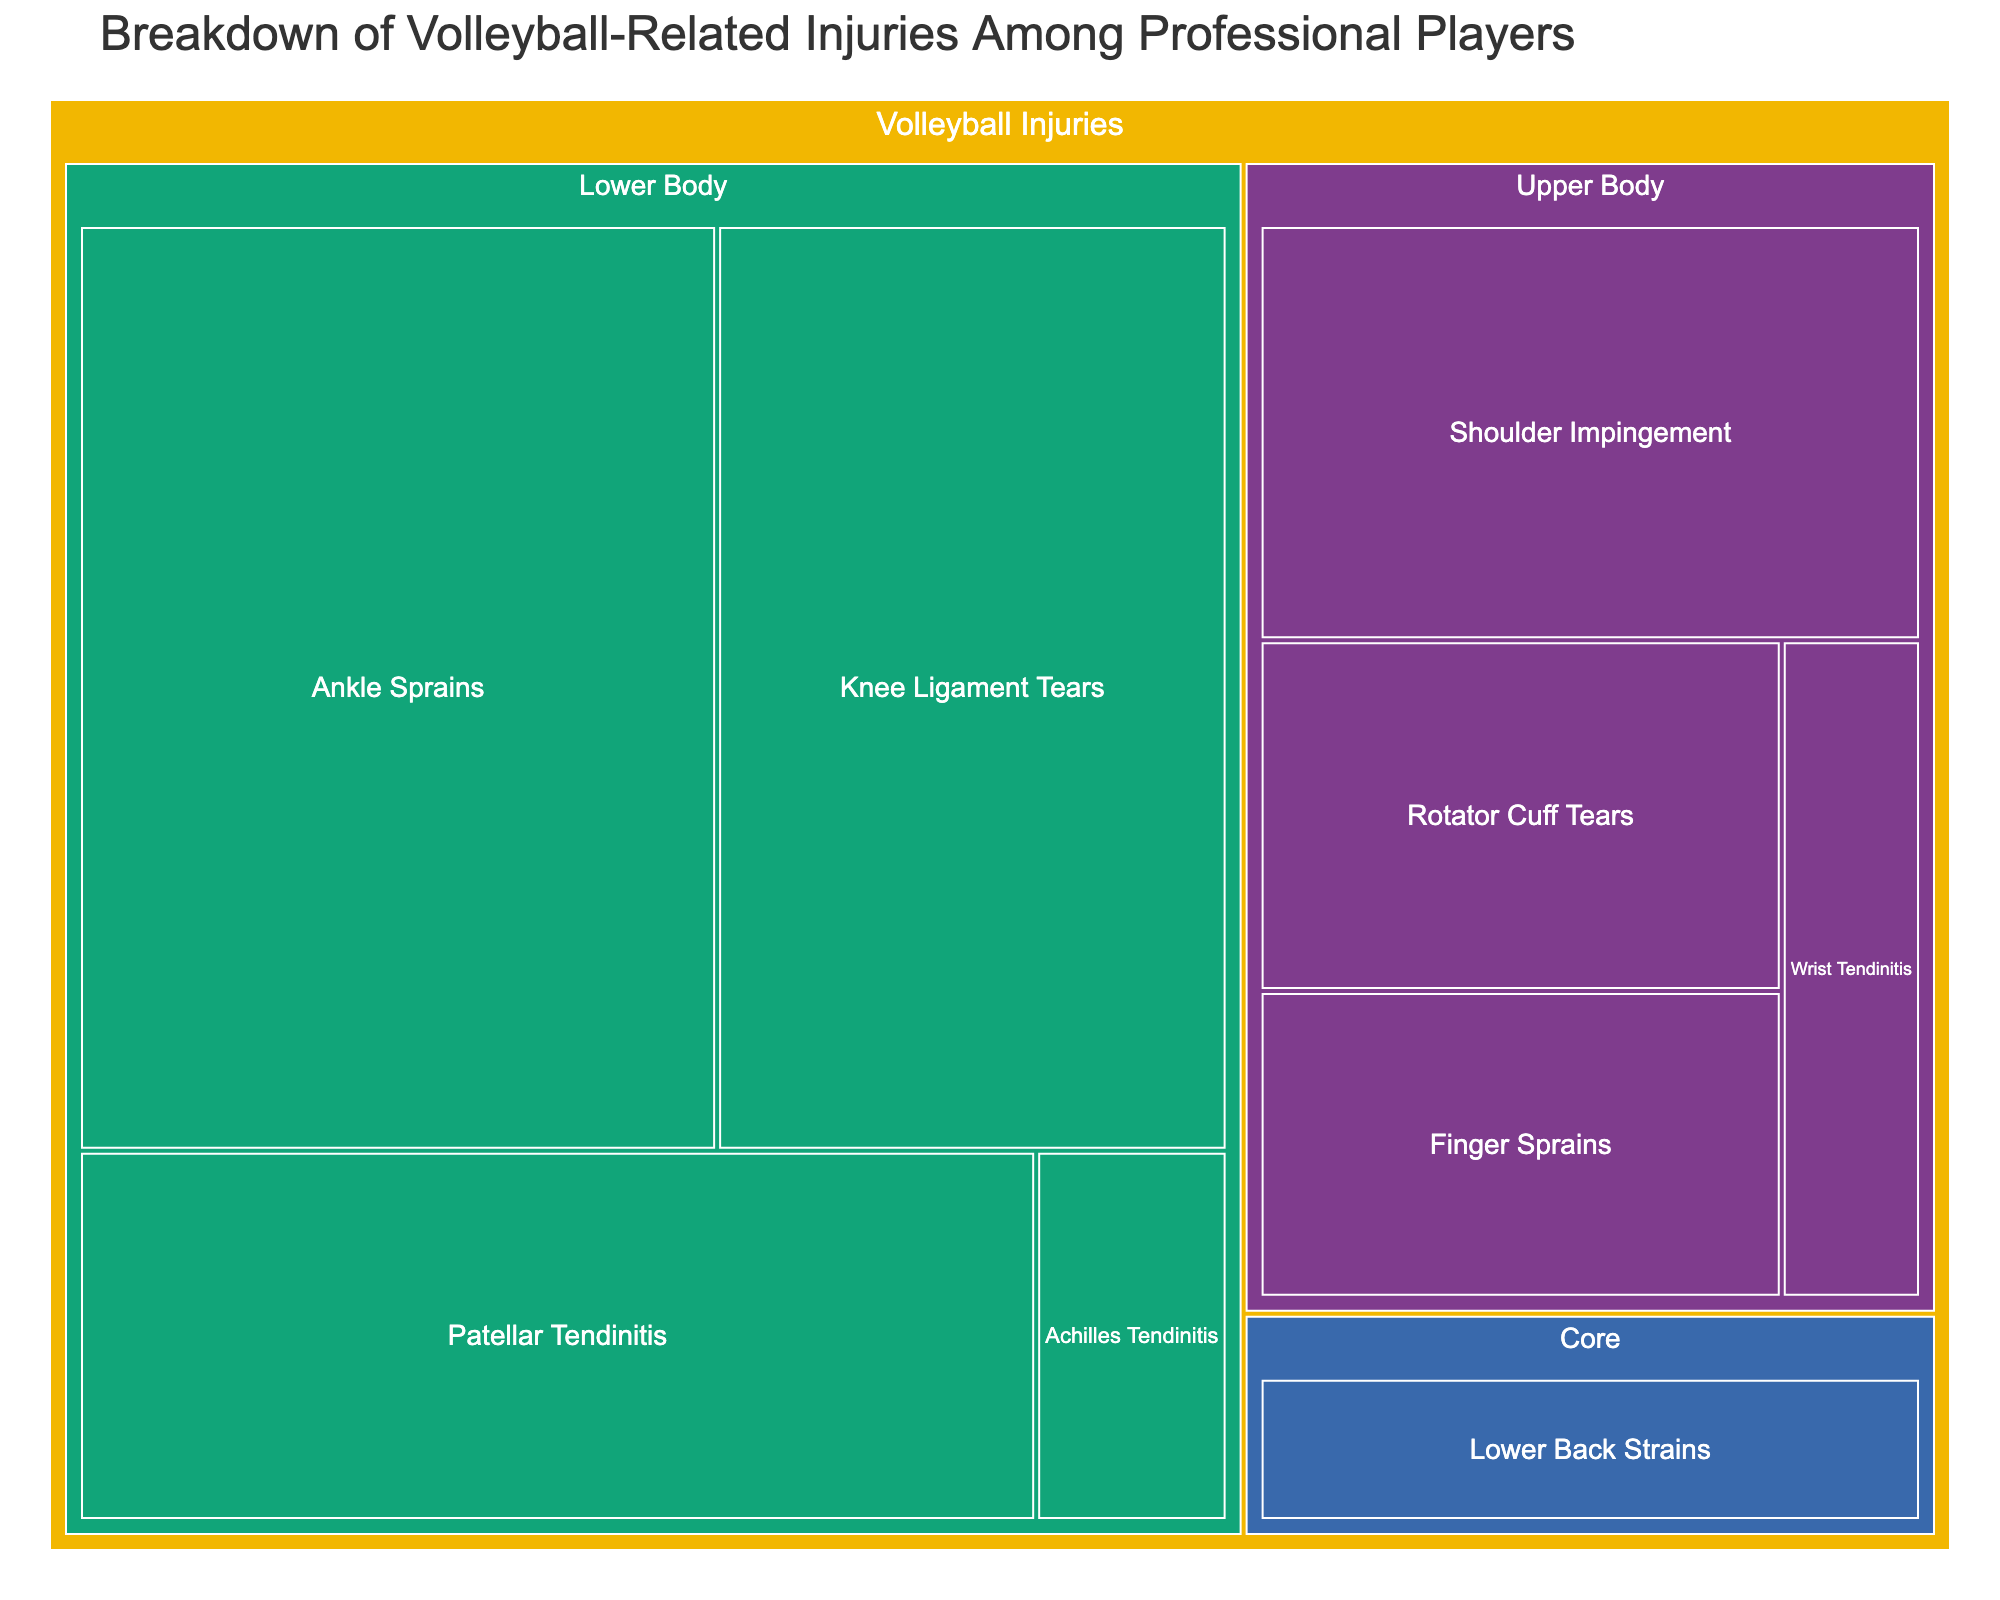What is the title of the treemap? The title can be found at the top of the treemap. It provides an overview of what the treemap is depicting.
Answer: Breakdown of Volleyball-Related Injuries Among Professional Players Which body part has the highest percentage of injuries? Look at the size of the rectangles representing different body parts in the treemap to determine which one is the largest.
Answer: Lower Body What percentage of injuries are related to the shoulder? Locate the rectangle labeled "Shoulder Impingement" and check its percentage value.
Answer: 12% What's the combined percentage of knee ligament tears and Achilles tendinitis? To find this, add the percentages of knee ligament tears and Achilles tendinitis from the treemap. 20% + 3% = 23%
Answer: 23% Which injury type affecting the upper body has the lowest percentage? Check the injury types under the "Upper Body" category and find the one with the smallest percentage.
Answer: Wrist Tendinitis What is the total percentage of injuries classified under "Core"? There is only one injury type listed under "Core" - Lower Back Strains. Check its percentage value.
Answer: 6% How many injury types are shown for the lower body? Count the number of rectangles under the "Lower Body" category in the treemap.
Answer: 4 How does the percentage of finger sprains compare to shoulder impingement? Compare the percentage values of finger sprains and shoulder impingement. Finger sprains have 7%, and shoulder impingement has 12%. Finger sprains are less.
Answer: Finger Sprains have a lower percentage Which lower body injury type has the second highest percentage? Within the "Lower Body" category, find the injury with the second highest percentage by comparing the values. Ankle Sprains are 25%, Knee Ligament Tears are 20%, Patellar Tendinitis is 15%, and Achilles Tendinitis is 3%. Knee Ligament Tears have the second highest.
Answer: Knee Ligament Tears What is the difference in percentage between rotator cuff tears and patellar tendinitis? Subtract the percentage of rotator cuff tears from patellar tendinitis. 15% - 8% = 7%
Answer: 7% 